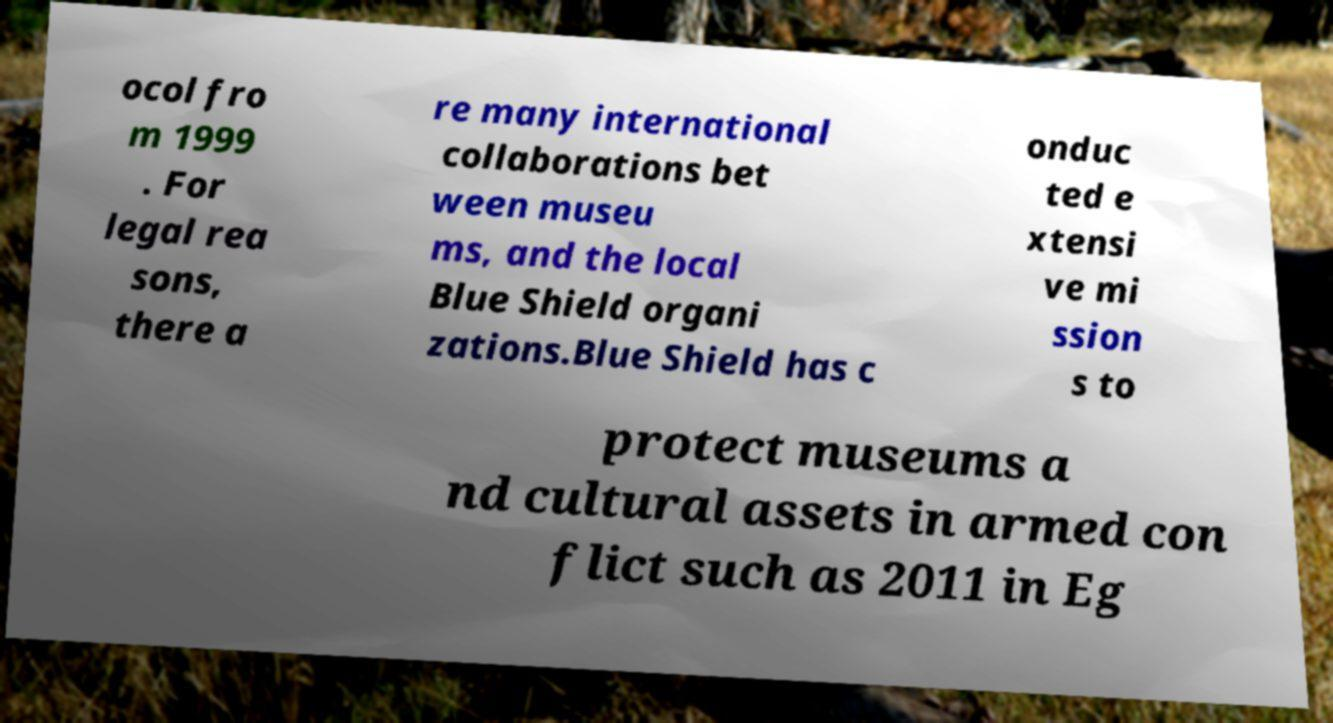For documentation purposes, I need the text within this image transcribed. Could you provide that? ocol fro m 1999 . For legal rea sons, there a re many international collaborations bet ween museu ms, and the local Blue Shield organi zations.Blue Shield has c onduc ted e xtensi ve mi ssion s to protect museums a nd cultural assets in armed con flict such as 2011 in Eg 